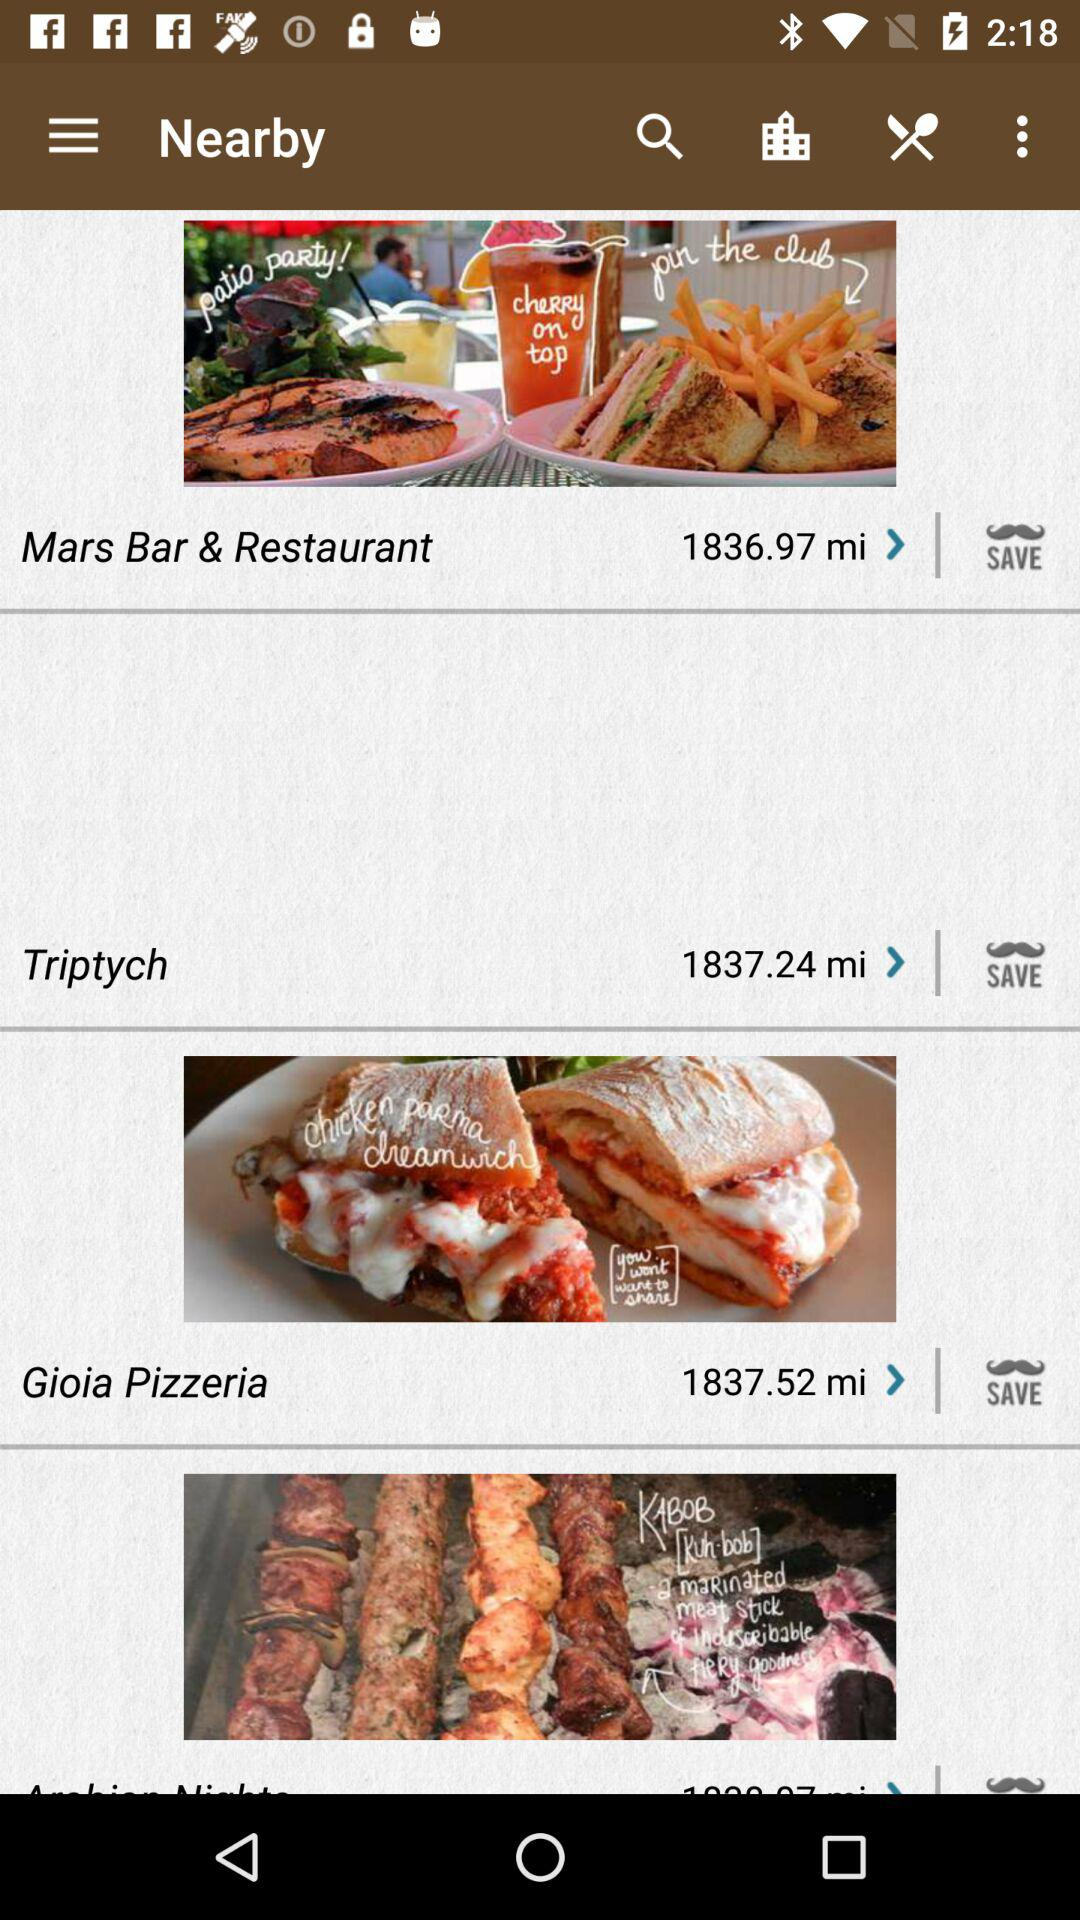At what distance is Gioia Pizzeria located from my location? The distance is 1837.52 miles. 